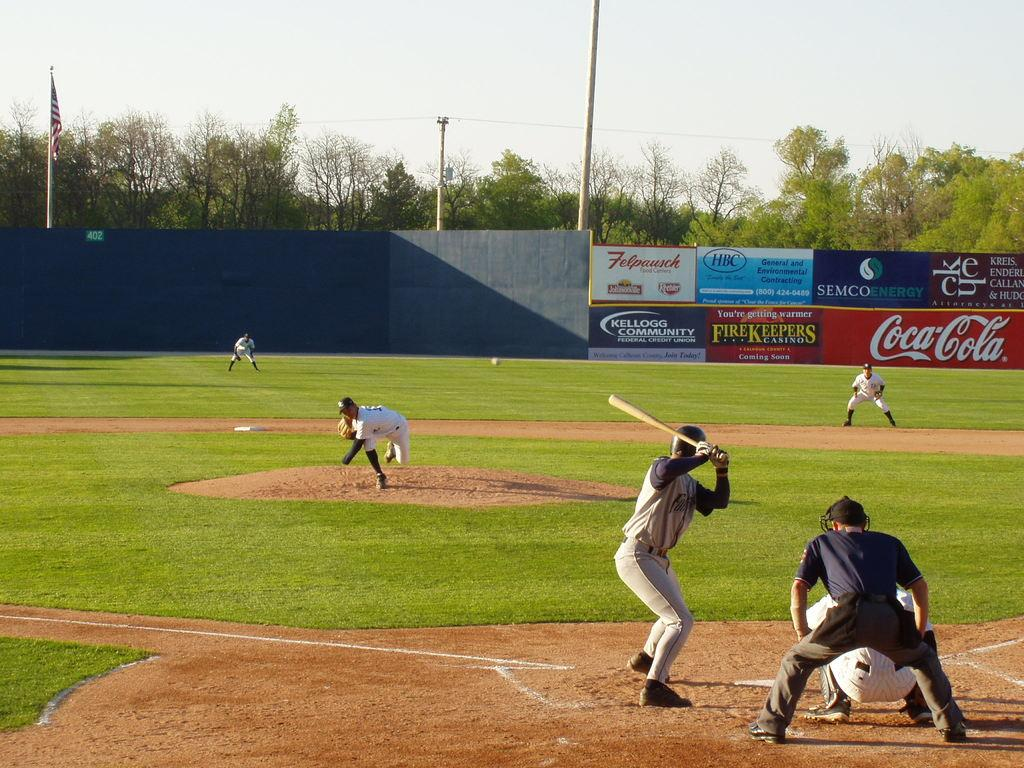<image>
Create a compact narrative representing the image presented. Coca Cola is one of the sponsors of the baseball game 